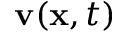<formula> <loc_0><loc_0><loc_500><loc_500>v ( { x } , t )</formula> 